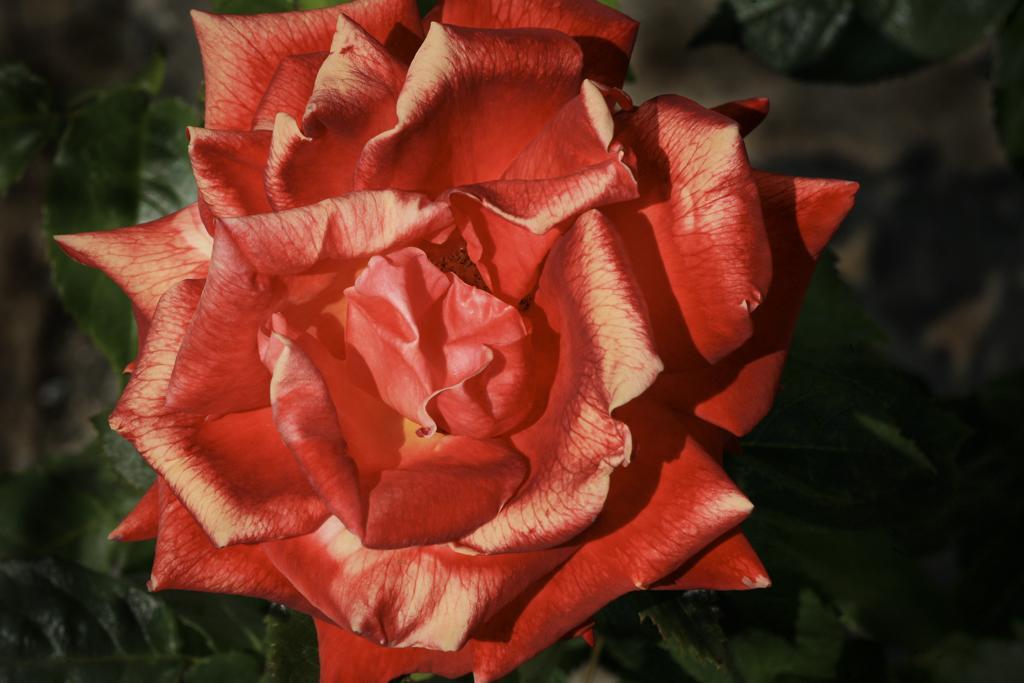How would you summarize this image in a sentence or two? This picture seems to be clicked outside. In the center there is a flower and we can see the green leaves and the plants. 